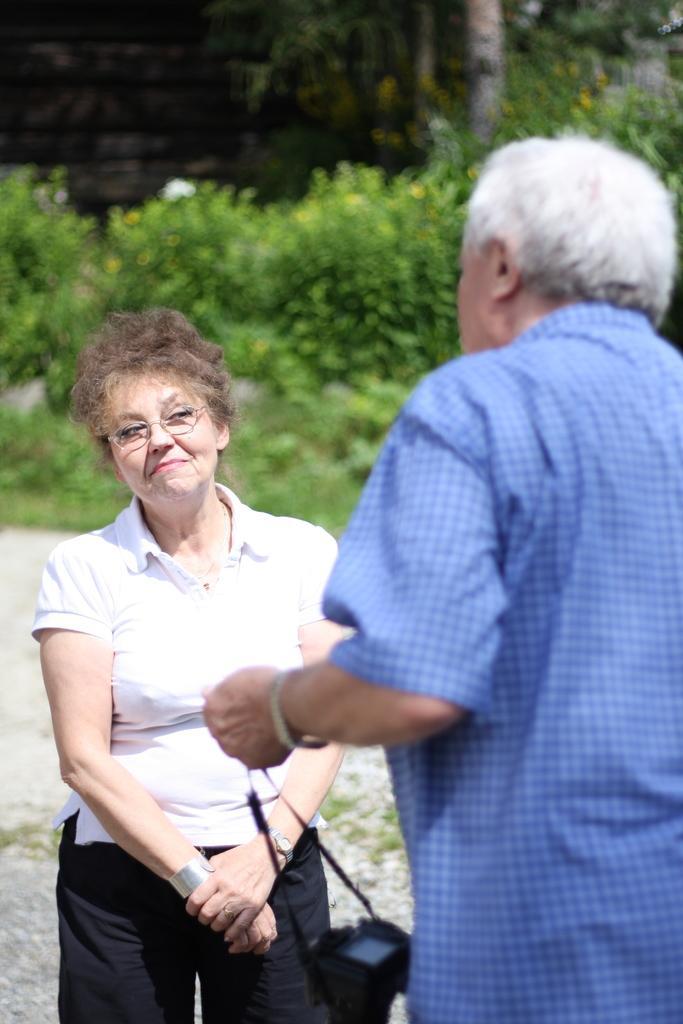Could you give a brief overview of what you see in this image? In this picture I can see a man and a woman standing, man holding a camera, and in the background there are plants and trees. 